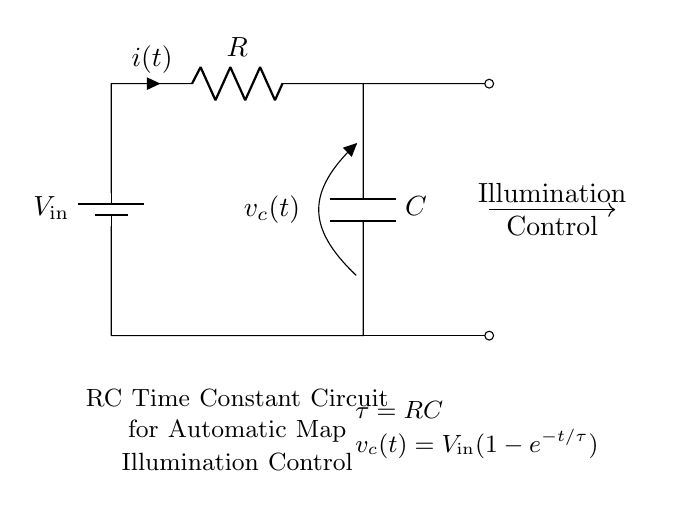What is the input voltage of the circuit? The input voltage is labeled as \( V_\text{in} \) in the circuit. It serves as the power supply for the entire circuit.
Answer: V_in What components are present in this circuit? The circuit contains a resistor, a capacitor, and a battery. These components are essential for creating an RC time constant circuit.
Answer: Resistor, Capacitor, Battery What does \( \tau \) represent in this circuit? \( \tau \) represents the time constant of the RC circuit, calculated by multiplying the resistance \( R \) by the capacitance \( C \). It indicates how quickly the capacitor charges or discharges.
Answer: RC What does \( v_c(t) \) represent in this circuit? \( v_c(t) \) represents the voltage across the capacitor as a function of time, showing how the voltage changes as the capacitor charges over time.
Answer: Voltage across capacitor How does the illumination control work in this circuit? The illumination control is governed by the voltage across the capacitor \( v_c(t) \), which increases over time as the capacitor charges, controlling how bright the map illumination becomes based on the input voltage.
Answer: By controlling voltage across capacitor What happens to the voltage across the capacitor when time approaches infinity? As time approaches infinity, the capacitor voltage \( v_c(t) \) approaches the input voltage \( V_\text{in} \), meaning the capacitor is fully charged and no longer affects the circuit's operation.
Answer: V_in What is the role of the resistor in this circuit? The resistor limits the current flowing through the circuit, which controls the rate at which the capacitor charges. This affects the time constant \( \tau \) of the circuit.
Answer: Limit current 